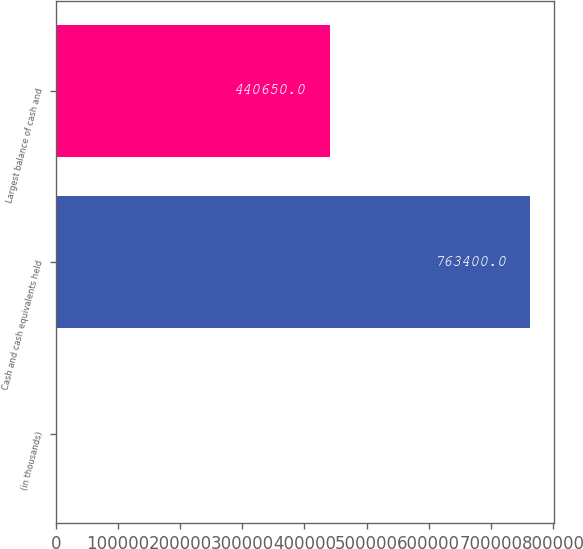Convert chart to OTSL. <chart><loc_0><loc_0><loc_500><loc_500><bar_chart><fcel>(in thousands)<fcel>Cash and cash equivalents held<fcel>Largest balance of cash and<nl><fcel>2015<fcel>763400<fcel>440650<nl></chart> 